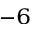Convert formula to latex. <formula><loc_0><loc_0><loc_500><loc_500>^ { - 6 }</formula> 